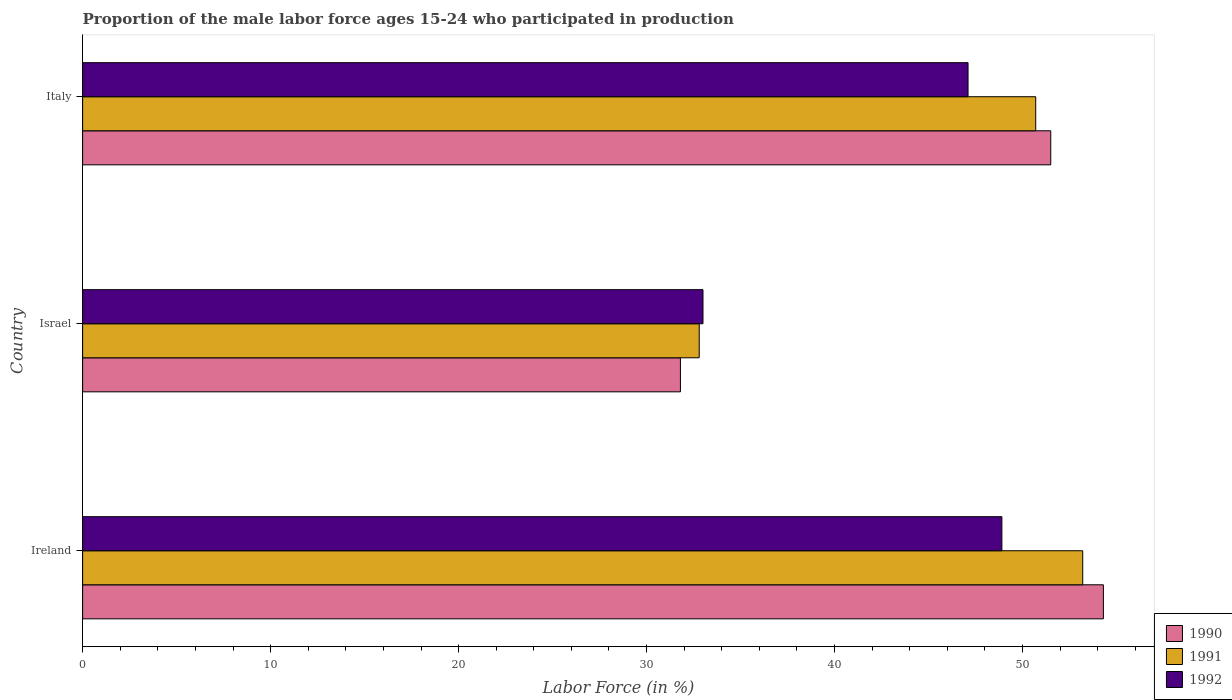Are the number of bars per tick equal to the number of legend labels?
Give a very brief answer. Yes. How many bars are there on the 3rd tick from the top?
Give a very brief answer. 3. What is the label of the 3rd group of bars from the top?
Your answer should be very brief. Ireland. What is the proportion of the male labor force who participated in production in 1991 in Ireland?
Keep it short and to the point. 53.2. Across all countries, what is the maximum proportion of the male labor force who participated in production in 1990?
Ensure brevity in your answer.  54.3. Across all countries, what is the minimum proportion of the male labor force who participated in production in 1990?
Provide a short and direct response. 31.8. In which country was the proportion of the male labor force who participated in production in 1992 maximum?
Provide a succinct answer. Ireland. What is the total proportion of the male labor force who participated in production in 1992 in the graph?
Offer a very short reply. 129. What is the difference between the proportion of the male labor force who participated in production in 1991 in Israel and that in Italy?
Your response must be concise. -17.9. What is the difference between the proportion of the male labor force who participated in production in 1991 in Italy and the proportion of the male labor force who participated in production in 1992 in Ireland?
Keep it short and to the point. 1.8. What is the difference between the proportion of the male labor force who participated in production in 1991 and proportion of the male labor force who participated in production in 1990 in Italy?
Your answer should be compact. -0.8. What is the ratio of the proportion of the male labor force who participated in production in 1990 in Ireland to that in Israel?
Give a very brief answer. 1.71. Is the difference between the proportion of the male labor force who participated in production in 1991 in Ireland and Israel greater than the difference between the proportion of the male labor force who participated in production in 1990 in Ireland and Israel?
Provide a succinct answer. No. What is the difference between the highest and the second highest proportion of the male labor force who participated in production in 1990?
Your response must be concise. 2.8. What is the difference between the highest and the lowest proportion of the male labor force who participated in production in 1990?
Give a very brief answer. 22.5. In how many countries, is the proportion of the male labor force who participated in production in 1990 greater than the average proportion of the male labor force who participated in production in 1990 taken over all countries?
Provide a short and direct response. 2. Is the sum of the proportion of the male labor force who participated in production in 1992 in Ireland and Israel greater than the maximum proportion of the male labor force who participated in production in 1990 across all countries?
Offer a very short reply. Yes. What does the 2nd bar from the top in Ireland represents?
Provide a succinct answer. 1991. What does the 2nd bar from the bottom in Israel represents?
Ensure brevity in your answer.  1991. Is it the case that in every country, the sum of the proportion of the male labor force who participated in production in 1990 and proportion of the male labor force who participated in production in 1991 is greater than the proportion of the male labor force who participated in production in 1992?
Offer a very short reply. Yes. How many bars are there?
Your answer should be compact. 9. Are all the bars in the graph horizontal?
Your response must be concise. Yes. How many countries are there in the graph?
Your response must be concise. 3. What is the difference between two consecutive major ticks on the X-axis?
Provide a succinct answer. 10. Does the graph contain any zero values?
Your response must be concise. No. Does the graph contain grids?
Give a very brief answer. No. How many legend labels are there?
Offer a very short reply. 3. What is the title of the graph?
Your response must be concise. Proportion of the male labor force ages 15-24 who participated in production. Does "2014" appear as one of the legend labels in the graph?
Make the answer very short. No. What is the label or title of the X-axis?
Provide a short and direct response. Labor Force (in %). What is the label or title of the Y-axis?
Offer a terse response. Country. What is the Labor Force (in %) in 1990 in Ireland?
Your answer should be very brief. 54.3. What is the Labor Force (in %) in 1991 in Ireland?
Give a very brief answer. 53.2. What is the Labor Force (in %) in 1992 in Ireland?
Provide a succinct answer. 48.9. What is the Labor Force (in %) of 1990 in Israel?
Provide a succinct answer. 31.8. What is the Labor Force (in %) in 1991 in Israel?
Your answer should be very brief. 32.8. What is the Labor Force (in %) of 1992 in Israel?
Your response must be concise. 33. What is the Labor Force (in %) in 1990 in Italy?
Your answer should be compact. 51.5. What is the Labor Force (in %) of 1991 in Italy?
Your answer should be compact. 50.7. What is the Labor Force (in %) in 1992 in Italy?
Make the answer very short. 47.1. Across all countries, what is the maximum Labor Force (in %) of 1990?
Give a very brief answer. 54.3. Across all countries, what is the maximum Labor Force (in %) in 1991?
Offer a terse response. 53.2. Across all countries, what is the maximum Labor Force (in %) in 1992?
Ensure brevity in your answer.  48.9. Across all countries, what is the minimum Labor Force (in %) in 1990?
Your response must be concise. 31.8. Across all countries, what is the minimum Labor Force (in %) of 1991?
Provide a short and direct response. 32.8. Across all countries, what is the minimum Labor Force (in %) in 1992?
Give a very brief answer. 33. What is the total Labor Force (in %) of 1990 in the graph?
Provide a succinct answer. 137.6. What is the total Labor Force (in %) in 1991 in the graph?
Give a very brief answer. 136.7. What is the total Labor Force (in %) of 1992 in the graph?
Give a very brief answer. 129. What is the difference between the Labor Force (in %) in 1991 in Ireland and that in Israel?
Ensure brevity in your answer.  20.4. What is the difference between the Labor Force (in %) in 1990 in Ireland and that in Italy?
Your answer should be very brief. 2.8. What is the difference between the Labor Force (in %) in 1992 in Ireland and that in Italy?
Your answer should be compact. 1.8. What is the difference between the Labor Force (in %) in 1990 in Israel and that in Italy?
Your response must be concise. -19.7. What is the difference between the Labor Force (in %) of 1991 in Israel and that in Italy?
Give a very brief answer. -17.9. What is the difference between the Labor Force (in %) in 1992 in Israel and that in Italy?
Provide a succinct answer. -14.1. What is the difference between the Labor Force (in %) of 1990 in Ireland and the Labor Force (in %) of 1992 in Israel?
Offer a terse response. 21.3. What is the difference between the Labor Force (in %) of 1991 in Ireland and the Labor Force (in %) of 1992 in Israel?
Keep it short and to the point. 20.2. What is the difference between the Labor Force (in %) in 1990 in Ireland and the Labor Force (in %) in 1991 in Italy?
Your answer should be very brief. 3.6. What is the difference between the Labor Force (in %) in 1990 in Ireland and the Labor Force (in %) in 1992 in Italy?
Keep it short and to the point. 7.2. What is the difference between the Labor Force (in %) in 1991 in Ireland and the Labor Force (in %) in 1992 in Italy?
Keep it short and to the point. 6.1. What is the difference between the Labor Force (in %) of 1990 in Israel and the Labor Force (in %) of 1991 in Italy?
Provide a short and direct response. -18.9. What is the difference between the Labor Force (in %) of 1990 in Israel and the Labor Force (in %) of 1992 in Italy?
Ensure brevity in your answer.  -15.3. What is the difference between the Labor Force (in %) of 1991 in Israel and the Labor Force (in %) of 1992 in Italy?
Make the answer very short. -14.3. What is the average Labor Force (in %) of 1990 per country?
Your answer should be very brief. 45.87. What is the average Labor Force (in %) in 1991 per country?
Your answer should be very brief. 45.57. What is the average Labor Force (in %) of 1992 per country?
Provide a succinct answer. 43. What is the difference between the Labor Force (in %) in 1990 and Labor Force (in %) in 1991 in Ireland?
Your response must be concise. 1.1. What is the difference between the Labor Force (in %) of 1990 and Labor Force (in %) of 1992 in Ireland?
Offer a very short reply. 5.4. What is the difference between the Labor Force (in %) in 1990 and Labor Force (in %) in 1991 in Israel?
Provide a succinct answer. -1. What is the difference between the Labor Force (in %) in 1990 and Labor Force (in %) in 1992 in Israel?
Ensure brevity in your answer.  -1.2. What is the difference between the Labor Force (in %) in 1991 and Labor Force (in %) in 1992 in Israel?
Ensure brevity in your answer.  -0.2. What is the difference between the Labor Force (in %) of 1990 and Labor Force (in %) of 1992 in Italy?
Offer a terse response. 4.4. What is the difference between the Labor Force (in %) of 1991 and Labor Force (in %) of 1992 in Italy?
Offer a very short reply. 3.6. What is the ratio of the Labor Force (in %) in 1990 in Ireland to that in Israel?
Make the answer very short. 1.71. What is the ratio of the Labor Force (in %) in 1991 in Ireland to that in Israel?
Keep it short and to the point. 1.62. What is the ratio of the Labor Force (in %) in 1992 in Ireland to that in Israel?
Provide a short and direct response. 1.48. What is the ratio of the Labor Force (in %) in 1990 in Ireland to that in Italy?
Give a very brief answer. 1.05. What is the ratio of the Labor Force (in %) of 1991 in Ireland to that in Italy?
Give a very brief answer. 1.05. What is the ratio of the Labor Force (in %) in 1992 in Ireland to that in Italy?
Your answer should be compact. 1.04. What is the ratio of the Labor Force (in %) of 1990 in Israel to that in Italy?
Your answer should be very brief. 0.62. What is the ratio of the Labor Force (in %) in 1991 in Israel to that in Italy?
Offer a very short reply. 0.65. What is the ratio of the Labor Force (in %) of 1992 in Israel to that in Italy?
Your answer should be very brief. 0.7. What is the difference between the highest and the second highest Labor Force (in %) of 1990?
Give a very brief answer. 2.8. What is the difference between the highest and the second highest Labor Force (in %) in 1992?
Ensure brevity in your answer.  1.8. What is the difference between the highest and the lowest Labor Force (in %) in 1991?
Ensure brevity in your answer.  20.4. What is the difference between the highest and the lowest Labor Force (in %) of 1992?
Give a very brief answer. 15.9. 